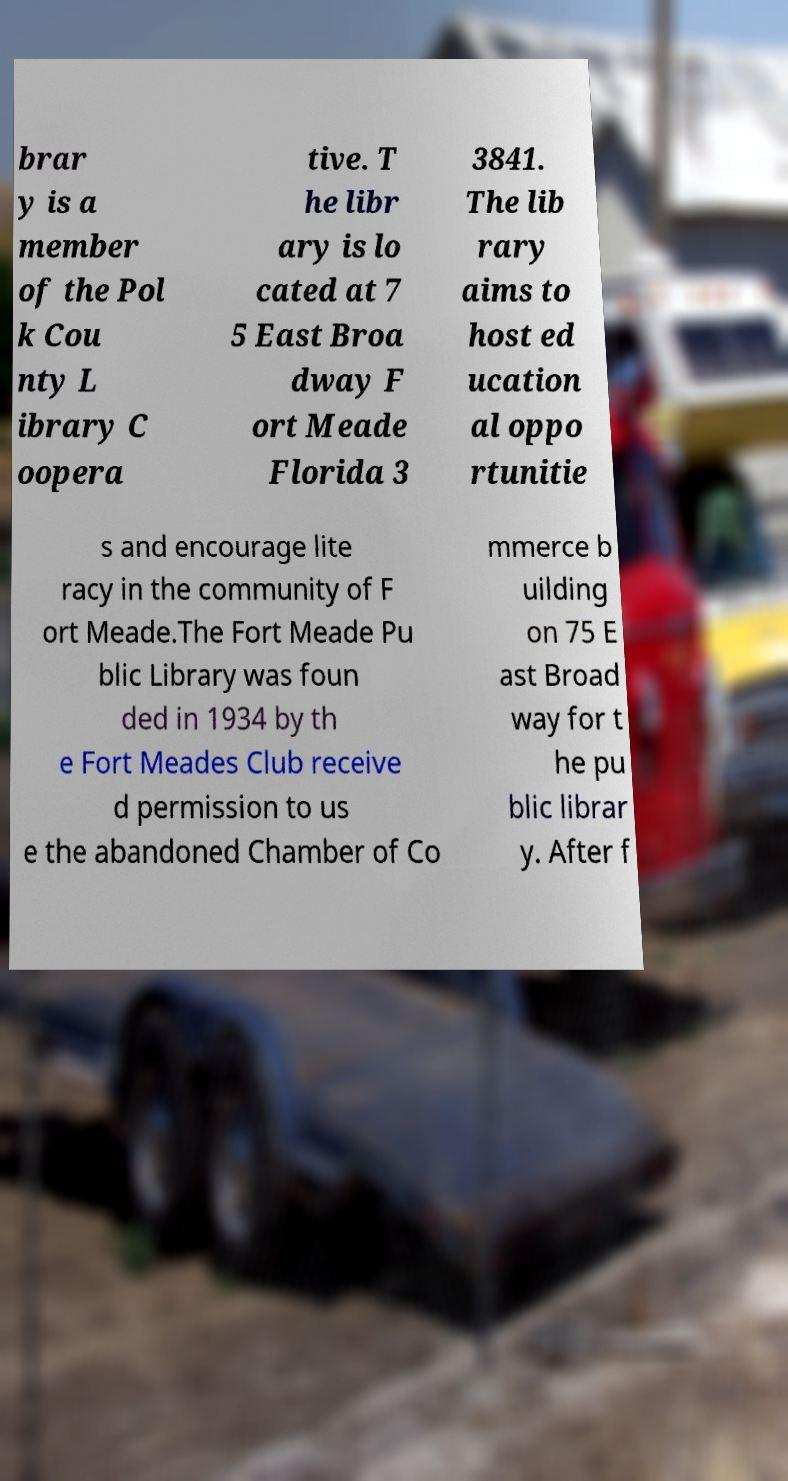Please read and relay the text visible in this image. What does it say? brar y is a member of the Pol k Cou nty L ibrary C oopera tive. T he libr ary is lo cated at 7 5 East Broa dway F ort Meade Florida 3 3841. The lib rary aims to host ed ucation al oppo rtunitie s and encourage lite racy in the community of F ort Meade.The Fort Meade Pu blic Library was foun ded in 1934 by th e Fort Meades Club receive d permission to us e the abandoned Chamber of Co mmerce b uilding on 75 E ast Broad way for t he pu blic librar y. After f 